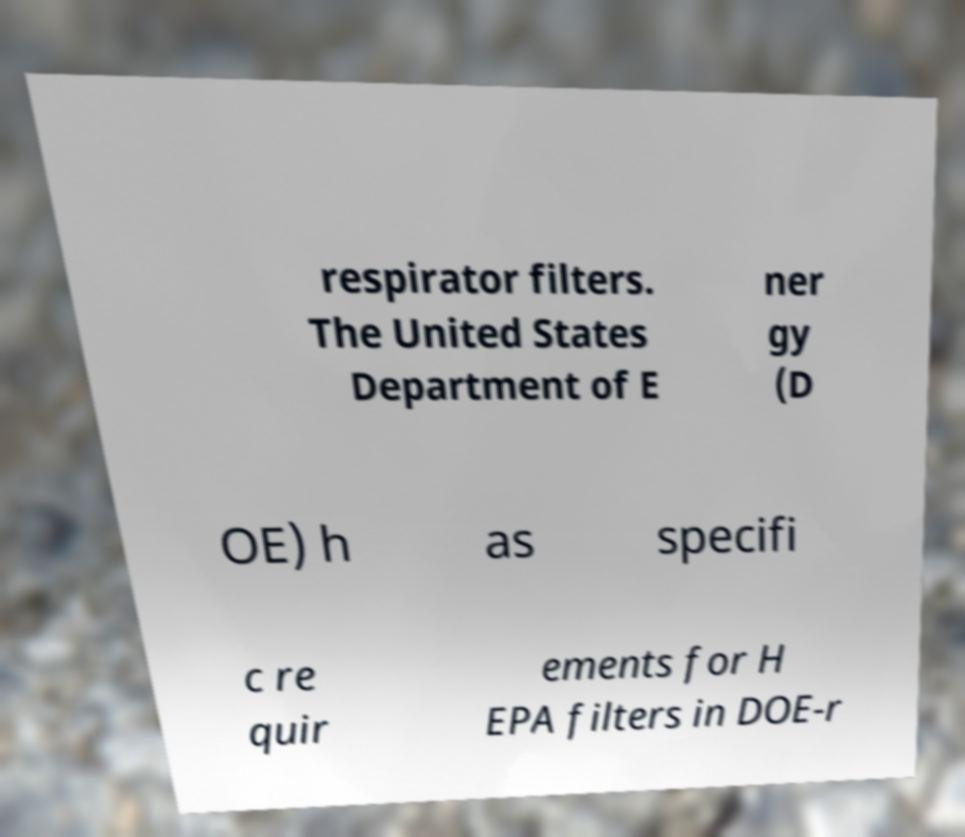Could you assist in decoding the text presented in this image and type it out clearly? respirator filters. The United States Department of E ner gy (D OE) h as specifi c re quir ements for H EPA filters in DOE-r 